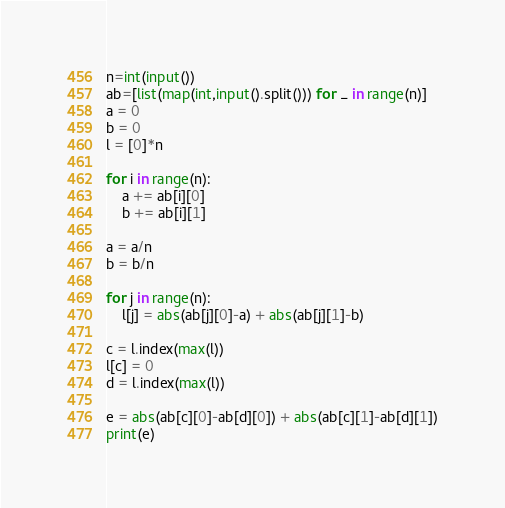<code> <loc_0><loc_0><loc_500><loc_500><_Python_>n=int(input())
ab=[list(map(int,input().split())) for _ in range(n)]
a = 0
b = 0
l = [0]*n

for i in range(n):
    a += ab[i][0]
    b += ab[i][1]

a = a/n
b = b/n

for j in range(n):
    l[j] = abs(ab[j][0]-a) + abs(ab[j][1]-b)

c = l.index(max(l))
l[c] = 0
d = l.index(max(l))

e = abs(ab[c][0]-ab[d][0]) + abs(ab[c][1]-ab[d][1])
print(e)</code> 